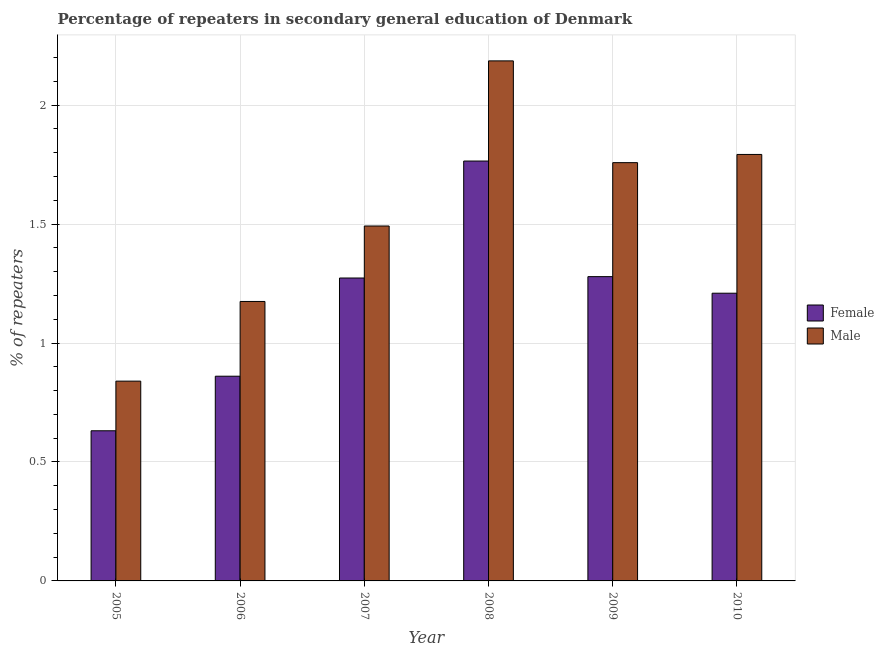How many groups of bars are there?
Offer a very short reply. 6. Are the number of bars on each tick of the X-axis equal?
Offer a terse response. Yes. How many bars are there on the 2nd tick from the right?
Provide a short and direct response. 2. What is the label of the 1st group of bars from the left?
Make the answer very short. 2005. What is the percentage of female repeaters in 2006?
Your response must be concise. 0.86. Across all years, what is the maximum percentage of female repeaters?
Your answer should be very brief. 1.77. Across all years, what is the minimum percentage of male repeaters?
Give a very brief answer. 0.84. What is the total percentage of female repeaters in the graph?
Provide a succinct answer. 7.02. What is the difference between the percentage of male repeaters in 2008 and that in 2010?
Your response must be concise. 0.39. What is the difference between the percentage of female repeaters in 2008 and the percentage of male repeaters in 2010?
Your answer should be compact. 0.56. What is the average percentage of female repeaters per year?
Offer a terse response. 1.17. What is the ratio of the percentage of female repeaters in 2008 to that in 2010?
Your answer should be very brief. 1.46. What is the difference between the highest and the second highest percentage of male repeaters?
Give a very brief answer. 0.39. What is the difference between the highest and the lowest percentage of male repeaters?
Make the answer very short. 1.35. In how many years, is the percentage of female repeaters greater than the average percentage of female repeaters taken over all years?
Provide a succinct answer. 4. What does the 2nd bar from the left in 2010 represents?
Keep it short and to the point. Male. What does the 1st bar from the right in 2008 represents?
Make the answer very short. Male. What is the difference between two consecutive major ticks on the Y-axis?
Make the answer very short. 0.5. Are the values on the major ticks of Y-axis written in scientific E-notation?
Offer a terse response. No. Does the graph contain any zero values?
Give a very brief answer. No. Does the graph contain grids?
Your answer should be compact. Yes. Where does the legend appear in the graph?
Your answer should be very brief. Center right. What is the title of the graph?
Keep it short and to the point. Percentage of repeaters in secondary general education of Denmark. Does "Short-term debt" appear as one of the legend labels in the graph?
Give a very brief answer. No. What is the label or title of the Y-axis?
Offer a terse response. % of repeaters. What is the % of repeaters of Female in 2005?
Give a very brief answer. 0.63. What is the % of repeaters of Male in 2005?
Keep it short and to the point. 0.84. What is the % of repeaters of Female in 2006?
Your answer should be very brief. 0.86. What is the % of repeaters in Male in 2006?
Offer a very short reply. 1.17. What is the % of repeaters in Female in 2007?
Provide a succinct answer. 1.27. What is the % of repeaters in Male in 2007?
Offer a terse response. 1.49. What is the % of repeaters in Female in 2008?
Ensure brevity in your answer.  1.77. What is the % of repeaters of Male in 2008?
Provide a short and direct response. 2.19. What is the % of repeaters of Female in 2009?
Your answer should be very brief. 1.28. What is the % of repeaters of Male in 2009?
Ensure brevity in your answer.  1.76. What is the % of repeaters of Female in 2010?
Provide a short and direct response. 1.21. What is the % of repeaters in Male in 2010?
Provide a short and direct response. 1.79. Across all years, what is the maximum % of repeaters of Female?
Provide a short and direct response. 1.77. Across all years, what is the maximum % of repeaters of Male?
Your answer should be very brief. 2.19. Across all years, what is the minimum % of repeaters of Female?
Make the answer very short. 0.63. Across all years, what is the minimum % of repeaters in Male?
Provide a short and direct response. 0.84. What is the total % of repeaters in Female in the graph?
Your answer should be very brief. 7.02. What is the total % of repeaters of Male in the graph?
Provide a short and direct response. 9.24. What is the difference between the % of repeaters of Female in 2005 and that in 2006?
Ensure brevity in your answer.  -0.23. What is the difference between the % of repeaters in Male in 2005 and that in 2006?
Give a very brief answer. -0.33. What is the difference between the % of repeaters in Female in 2005 and that in 2007?
Your answer should be compact. -0.64. What is the difference between the % of repeaters in Male in 2005 and that in 2007?
Make the answer very short. -0.65. What is the difference between the % of repeaters in Female in 2005 and that in 2008?
Keep it short and to the point. -1.13. What is the difference between the % of repeaters of Male in 2005 and that in 2008?
Your answer should be compact. -1.35. What is the difference between the % of repeaters in Female in 2005 and that in 2009?
Provide a succinct answer. -0.65. What is the difference between the % of repeaters in Male in 2005 and that in 2009?
Your response must be concise. -0.92. What is the difference between the % of repeaters of Female in 2005 and that in 2010?
Ensure brevity in your answer.  -0.58. What is the difference between the % of repeaters of Male in 2005 and that in 2010?
Your answer should be compact. -0.95. What is the difference between the % of repeaters of Female in 2006 and that in 2007?
Give a very brief answer. -0.41. What is the difference between the % of repeaters in Male in 2006 and that in 2007?
Ensure brevity in your answer.  -0.32. What is the difference between the % of repeaters in Female in 2006 and that in 2008?
Offer a terse response. -0.9. What is the difference between the % of repeaters of Male in 2006 and that in 2008?
Ensure brevity in your answer.  -1.01. What is the difference between the % of repeaters in Female in 2006 and that in 2009?
Your answer should be compact. -0.42. What is the difference between the % of repeaters in Male in 2006 and that in 2009?
Keep it short and to the point. -0.58. What is the difference between the % of repeaters of Female in 2006 and that in 2010?
Your response must be concise. -0.35. What is the difference between the % of repeaters in Male in 2006 and that in 2010?
Your answer should be compact. -0.62. What is the difference between the % of repeaters in Female in 2007 and that in 2008?
Keep it short and to the point. -0.49. What is the difference between the % of repeaters in Male in 2007 and that in 2008?
Offer a very short reply. -0.69. What is the difference between the % of repeaters of Female in 2007 and that in 2009?
Keep it short and to the point. -0.01. What is the difference between the % of repeaters of Male in 2007 and that in 2009?
Your answer should be very brief. -0.27. What is the difference between the % of repeaters in Female in 2007 and that in 2010?
Offer a very short reply. 0.06. What is the difference between the % of repeaters of Male in 2007 and that in 2010?
Provide a succinct answer. -0.3. What is the difference between the % of repeaters of Female in 2008 and that in 2009?
Offer a terse response. 0.49. What is the difference between the % of repeaters in Male in 2008 and that in 2009?
Your response must be concise. 0.43. What is the difference between the % of repeaters of Female in 2008 and that in 2010?
Make the answer very short. 0.56. What is the difference between the % of repeaters in Male in 2008 and that in 2010?
Give a very brief answer. 0.39. What is the difference between the % of repeaters in Female in 2009 and that in 2010?
Make the answer very short. 0.07. What is the difference between the % of repeaters of Male in 2009 and that in 2010?
Your answer should be very brief. -0.03. What is the difference between the % of repeaters in Female in 2005 and the % of repeaters in Male in 2006?
Offer a terse response. -0.54. What is the difference between the % of repeaters in Female in 2005 and the % of repeaters in Male in 2007?
Provide a short and direct response. -0.86. What is the difference between the % of repeaters of Female in 2005 and the % of repeaters of Male in 2008?
Your answer should be compact. -1.56. What is the difference between the % of repeaters in Female in 2005 and the % of repeaters in Male in 2009?
Your response must be concise. -1.13. What is the difference between the % of repeaters in Female in 2005 and the % of repeaters in Male in 2010?
Your response must be concise. -1.16. What is the difference between the % of repeaters in Female in 2006 and the % of repeaters in Male in 2007?
Provide a short and direct response. -0.63. What is the difference between the % of repeaters in Female in 2006 and the % of repeaters in Male in 2008?
Your response must be concise. -1.33. What is the difference between the % of repeaters in Female in 2006 and the % of repeaters in Male in 2009?
Give a very brief answer. -0.9. What is the difference between the % of repeaters of Female in 2006 and the % of repeaters of Male in 2010?
Your answer should be compact. -0.93. What is the difference between the % of repeaters in Female in 2007 and the % of repeaters in Male in 2008?
Make the answer very short. -0.91. What is the difference between the % of repeaters in Female in 2007 and the % of repeaters in Male in 2009?
Offer a very short reply. -0.48. What is the difference between the % of repeaters of Female in 2007 and the % of repeaters of Male in 2010?
Offer a terse response. -0.52. What is the difference between the % of repeaters in Female in 2008 and the % of repeaters in Male in 2009?
Offer a terse response. 0.01. What is the difference between the % of repeaters of Female in 2008 and the % of repeaters of Male in 2010?
Your response must be concise. -0.03. What is the difference between the % of repeaters of Female in 2009 and the % of repeaters of Male in 2010?
Make the answer very short. -0.51. What is the average % of repeaters in Female per year?
Give a very brief answer. 1.17. What is the average % of repeaters of Male per year?
Ensure brevity in your answer.  1.54. In the year 2005, what is the difference between the % of repeaters of Female and % of repeaters of Male?
Make the answer very short. -0.21. In the year 2006, what is the difference between the % of repeaters in Female and % of repeaters in Male?
Provide a short and direct response. -0.31. In the year 2007, what is the difference between the % of repeaters of Female and % of repeaters of Male?
Give a very brief answer. -0.22. In the year 2008, what is the difference between the % of repeaters of Female and % of repeaters of Male?
Keep it short and to the point. -0.42. In the year 2009, what is the difference between the % of repeaters of Female and % of repeaters of Male?
Provide a short and direct response. -0.48. In the year 2010, what is the difference between the % of repeaters in Female and % of repeaters in Male?
Keep it short and to the point. -0.58. What is the ratio of the % of repeaters of Female in 2005 to that in 2006?
Offer a terse response. 0.73. What is the ratio of the % of repeaters of Male in 2005 to that in 2006?
Offer a terse response. 0.71. What is the ratio of the % of repeaters of Female in 2005 to that in 2007?
Offer a very short reply. 0.5. What is the ratio of the % of repeaters in Male in 2005 to that in 2007?
Offer a terse response. 0.56. What is the ratio of the % of repeaters of Female in 2005 to that in 2008?
Offer a very short reply. 0.36. What is the ratio of the % of repeaters of Male in 2005 to that in 2008?
Ensure brevity in your answer.  0.38. What is the ratio of the % of repeaters of Female in 2005 to that in 2009?
Keep it short and to the point. 0.49. What is the ratio of the % of repeaters of Male in 2005 to that in 2009?
Ensure brevity in your answer.  0.48. What is the ratio of the % of repeaters of Female in 2005 to that in 2010?
Your response must be concise. 0.52. What is the ratio of the % of repeaters of Male in 2005 to that in 2010?
Your answer should be very brief. 0.47. What is the ratio of the % of repeaters in Female in 2006 to that in 2007?
Offer a terse response. 0.68. What is the ratio of the % of repeaters of Male in 2006 to that in 2007?
Offer a terse response. 0.79. What is the ratio of the % of repeaters of Female in 2006 to that in 2008?
Offer a very short reply. 0.49. What is the ratio of the % of repeaters of Male in 2006 to that in 2008?
Provide a succinct answer. 0.54. What is the ratio of the % of repeaters in Female in 2006 to that in 2009?
Your response must be concise. 0.67. What is the ratio of the % of repeaters in Male in 2006 to that in 2009?
Ensure brevity in your answer.  0.67. What is the ratio of the % of repeaters of Female in 2006 to that in 2010?
Keep it short and to the point. 0.71. What is the ratio of the % of repeaters in Male in 2006 to that in 2010?
Ensure brevity in your answer.  0.66. What is the ratio of the % of repeaters in Female in 2007 to that in 2008?
Your answer should be compact. 0.72. What is the ratio of the % of repeaters in Male in 2007 to that in 2008?
Provide a short and direct response. 0.68. What is the ratio of the % of repeaters in Female in 2007 to that in 2009?
Your response must be concise. 1. What is the ratio of the % of repeaters in Male in 2007 to that in 2009?
Keep it short and to the point. 0.85. What is the ratio of the % of repeaters in Female in 2007 to that in 2010?
Your answer should be compact. 1.05. What is the ratio of the % of repeaters in Male in 2007 to that in 2010?
Ensure brevity in your answer.  0.83. What is the ratio of the % of repeaters in Female in 2008 to that in 2009?
Your answer should be very brief. 1.38. What is the ratio of the % of repeaters in Male in 2008 to that in 2009?
Offer a very short reply. 1.24. What is the ratio of the % of repeaters of Female in 2008 to that in 2010?
Offer a very short reply. 1.46. What is the ratio of the % of repeaters in Male in 2008 to that in 2010?
Offer a terse response. 1.22. What is the ratio of the % of repeaters in Female in 2009 to that in 2010?
Your answer should be compact. 1.06. What is the ratio of the % of repeaters in Male in 2009 to that in 2010?
Your response must be concise. 0.98. What is the difference between the highest and the second highest % of repeaters of Female?
Provide a succinct answer. 0.49. What is the difference between the highest and the second highest % of repeaters in Male?
Provide a short and direct response. 0.39. What is the difference between the highest and the lowest % of repeaters in Female?
Your answer should be very brief. 1.13. What is the difference between the highest and the lowest % of repeaters of Male?
Provide a succinct answer. 1.35. 